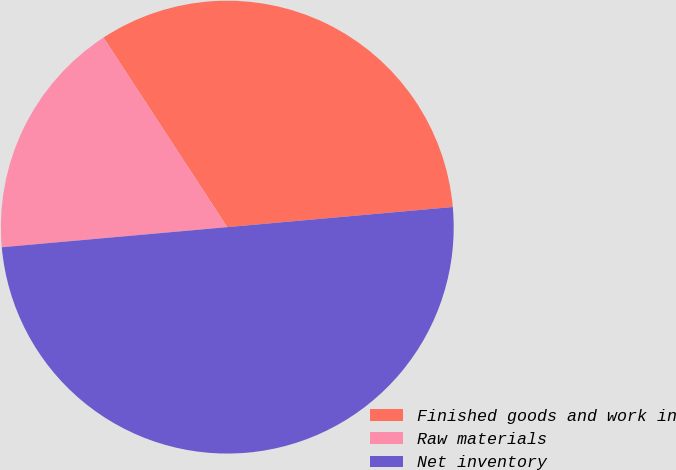Convert chart. <chart><loc_0><loc_0><loc_500><loc_500><pie_chart><fcel>Finished goods and work in<fcel>Raw materials<fcel>Net inventory<nl><fcel>32.79%<fcel>17.21%<fcel>50.0%<nl></chart> 